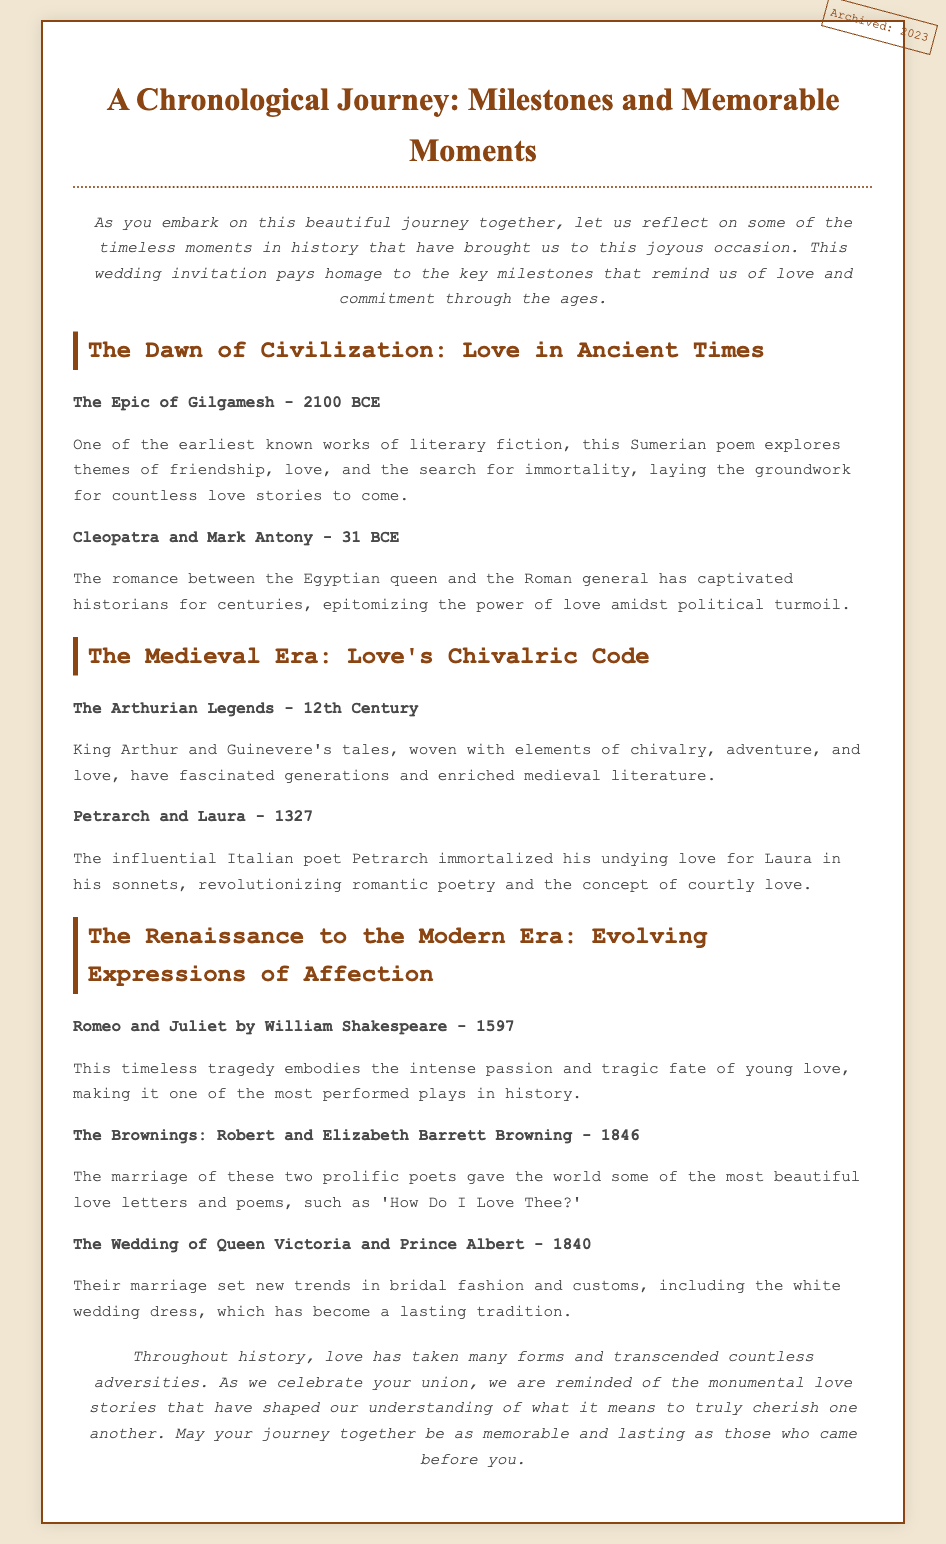what is the title of the document? The title of the document is the main heading, indicating the theme of the content.
Answer: A Chronological Journey: Milestones and Memorable Moments who wrote Romeo and Juliet? The author of the play is noted in the Renaissance section as part of the notable milestones in love.
Answer: William Shakespeare what year was The Wedding of Queen Victoria and Prince Albert? The wedding date is mentioned within the milestones, highlighting significant historical moments in love.
Answer: 1840 what is the earliest milestone mentioned in the document? The document starts with historical milestones, and the earliest one is highlighted in the Ancient Times section.
Answer: The Epic of Gilgamesh - 2100 BCE which poem by Petrarch is mentioned? The document references a specific figure known for his romantic poetry, indicating how courtly love evolved.
Answer: sonnets what theme is explored in The Epic of Gilgamesh? The document summarizes the themes of ancient works, revealing their influence on future love stories.
Answer: friendship, love, and the search for immortality what style is used for the section headers? The section headers follow a specific formatting style, emphasizing the transition between different time periods.
Answer: bold how does the conclusion refer to love throughout history? The conclusion summarizes the overarching theme of the document, reflecting on the significance of historical love stories.
Answer: myriad forms and transcended countless adversities what color is used for the document's background? The background color is described in the styling section of the document, which contributes to the overall appearance.
Answer: #f0e6d2 